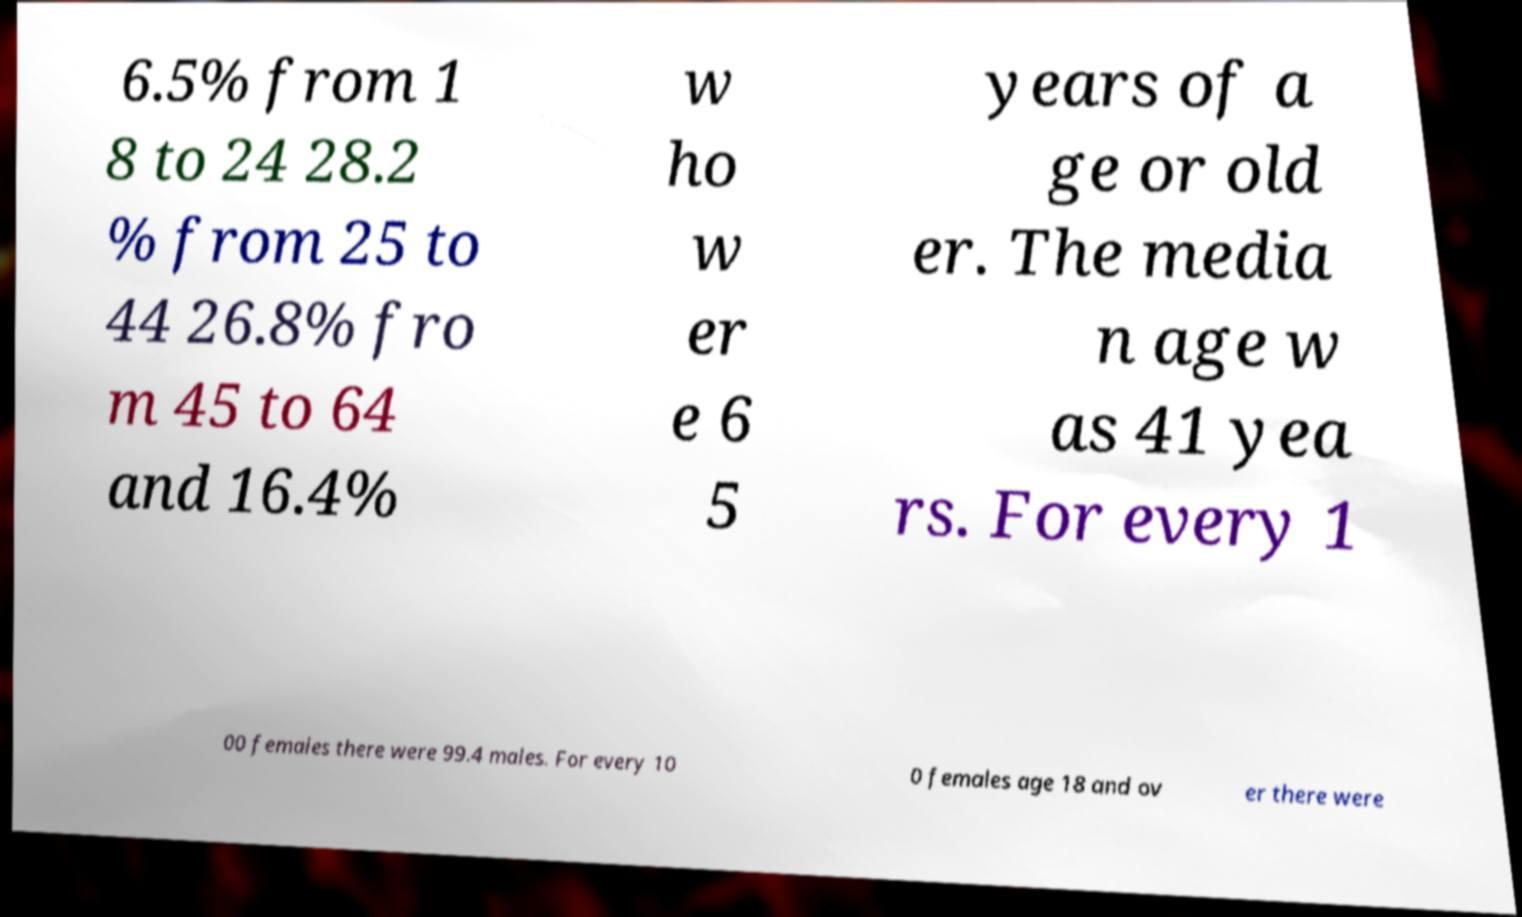What messages or text are displayed in this image? I need them in a readable, typed format. 6.5% from 1 8 to 24 28.2 % from 25 to 44 26.8% fro m 45 to 64 and 16.4% w ho w er e 6 5 years of a ge or old er. The media n age w as 41 yea rs. For every 1 00 females there were 99.4 males. For every 10 0 females age 18 and ov er there were 